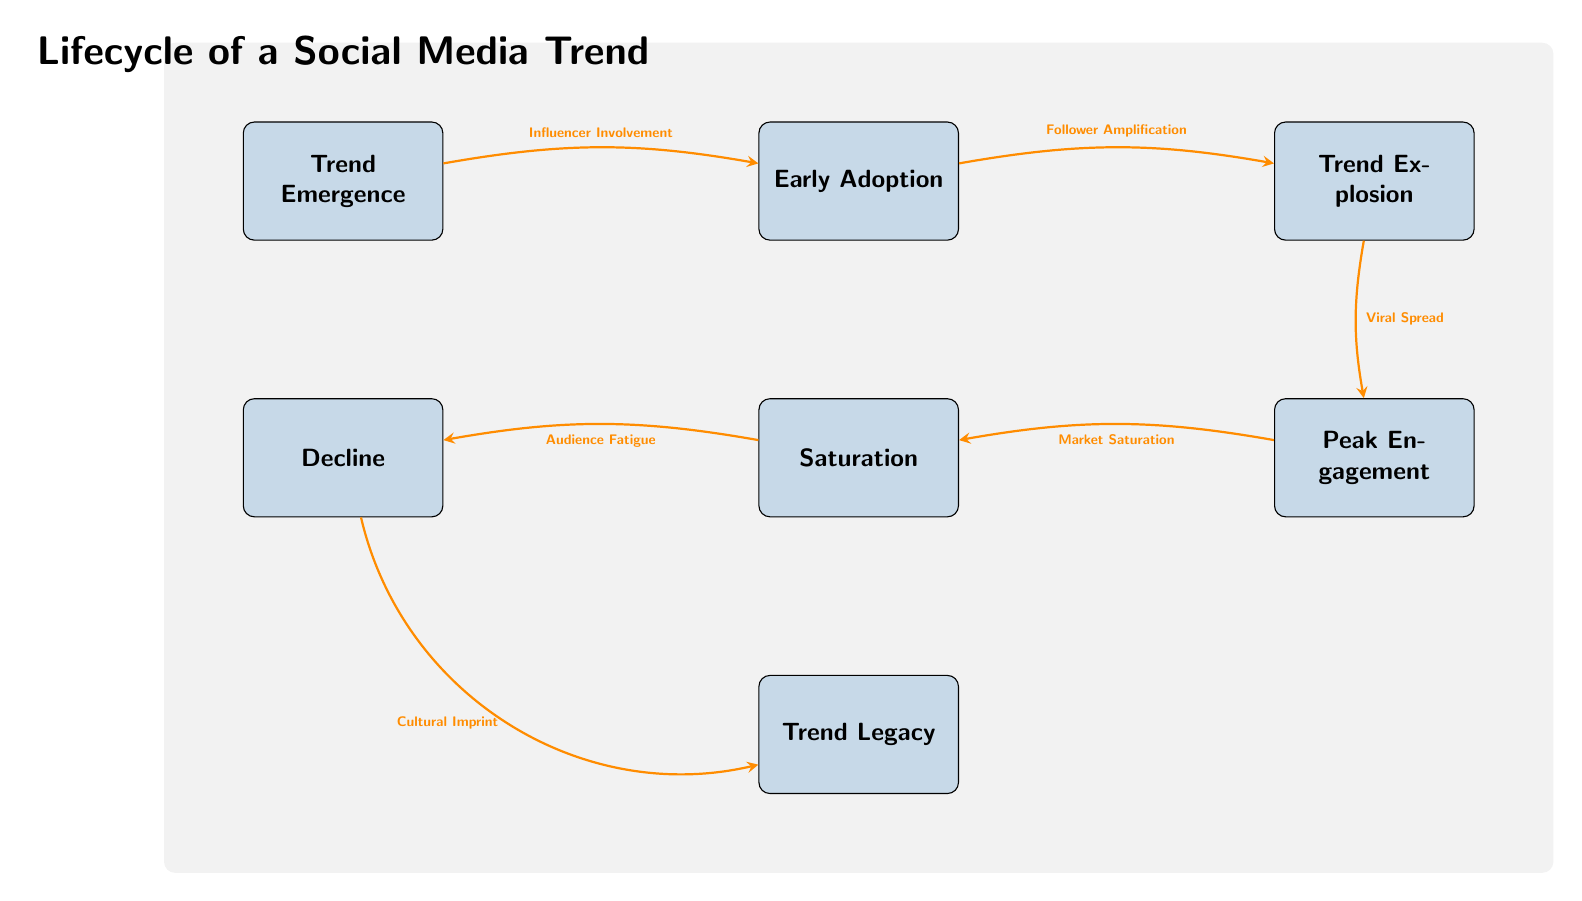What is the first step in the lifecycle of a social media trend? The diagram indicates that the first step is "Trend Emergence". It is the leftmost node in the sequence.
Answer: Trend Emergence How many total nodes are present in the diagram? Counting each labeled box in the diagram, we find a total of seven nodes: Trend Emergence, Early Adoption, Trend Explosion, Peak Engagement, Saturation, Decline, and Trend Legacy.
Answer: 7 What follows the "Early Adoption" stage? According to the diagram, the stage that follows "Early Adoption" is "Trend Explosion", as indicated by the rightward arrow connecting the two nodes.
Answer: Trend Explosion What type of involvement initially triggers the trend? The diagram shows that "Influencer Involvement" is the cause that triggers the shift from "Trend Emergence" to "Early Adoption", as marked by the arrow between these two nodes.
Answer: Influencer Involvement What happens as a result of "Peak Engagement"? The diagram identifies "Market Saturation" as the result of "Peak Engagement", demonstrated by the arrow pointing from the Peak Engagement node to the Saturation node.
Answer: Market Saturation At which point does "Cultural Imprint" occur? "Cultural Imprint" happens after "Decline", according to the flow of the diagram moving from the Decline node to the Trend Legacy node.
Answer: Trend Legacy What connects "Saturation" to "Decline"? The connection is labeled "Audience Fatigue", which is specified on the arrow pointing from Saturation to Decline in the diagram.
Answer: Audience Fatigue Why is "Viral Spread" significant in the lifecycle? "Viral Spread" plays a crucial role in indicating the transition between "Trend Explosion" and "Peak Engagement", showing how trends increase in visibility and reach exponentially during this period.
Answer: Viral Spread Which relationship signifies follower involvement? The relationship shown as "Follower Amplification" connects "Early Adoption" to "Trend Explosion", illustrating how followers contribute to the trend's momentum at this stage.
Answer: Follower Amplification 